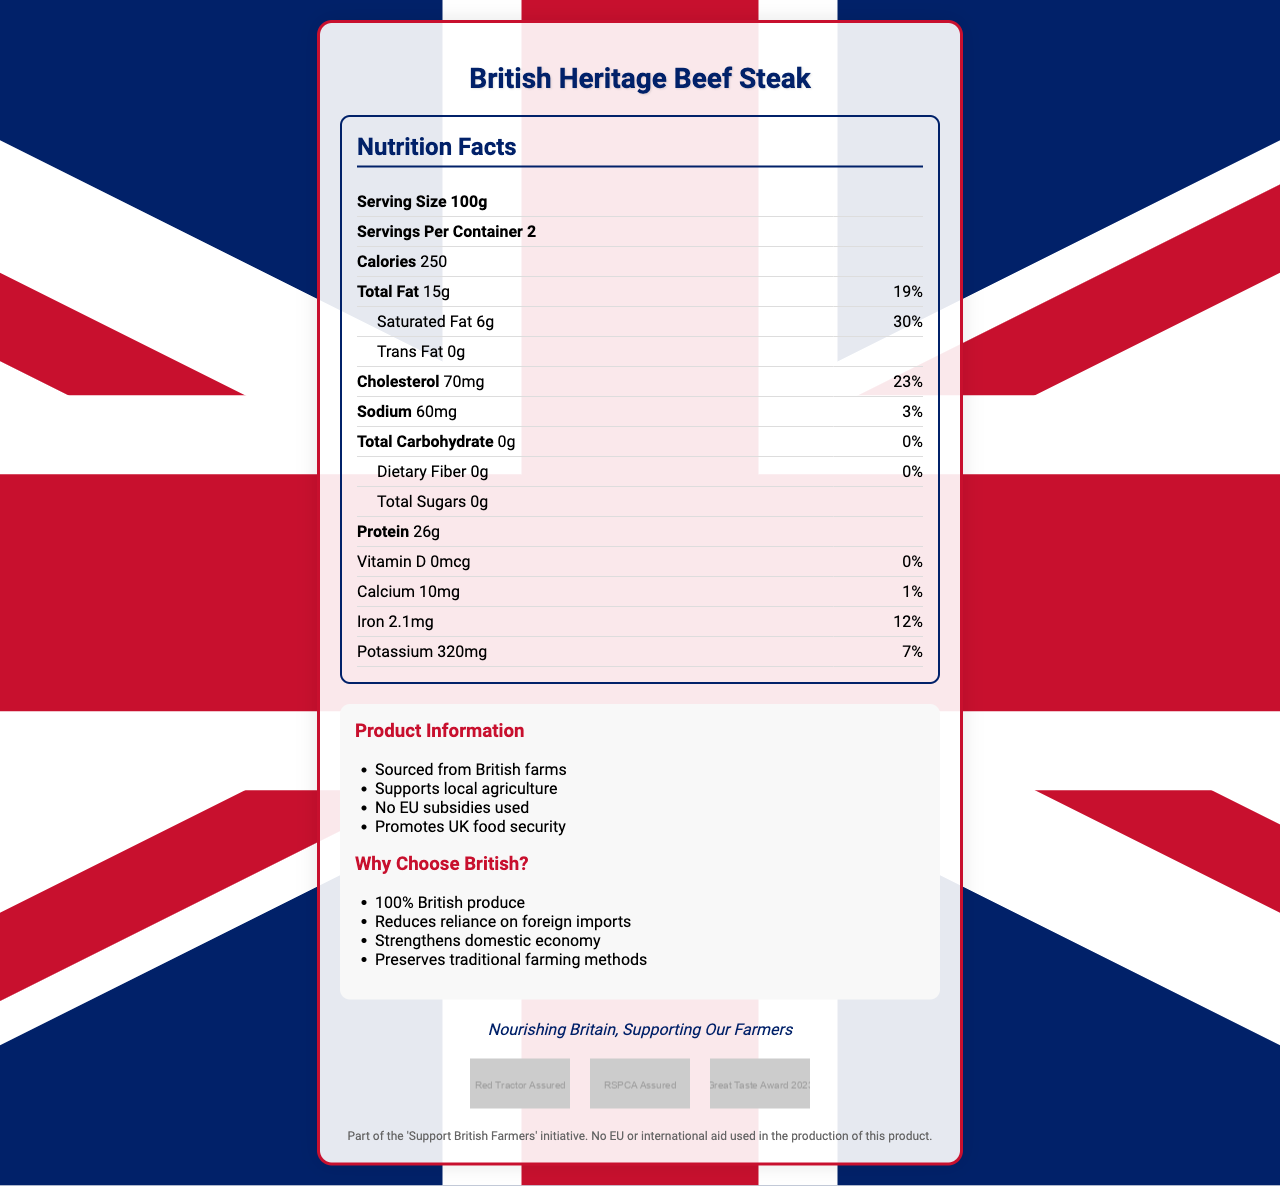What is the serving size of British Heritage Beef Steak? The serving size is listed explicitly in the nutrition facts section of the document.
Answer: 100g What is the percentage of daily value for saturated fat? The daily value percentage is listed next to the saturated fat amount of 6g in the nutrition facts table.
Answer: 30% How much iron is in one serving? The amount of iron per serving is specified in the nutrition facts.
Answer: 2.1mg What certifications does the British Heritage Beef Steak have? The certifications are displayed in the certifications section with the logos and names.
Answer: Red Tractor Assured, RSPCA Assured, Great Taste Award 2023 How many calories are there per container? Each serving has 250 calories and there are 2 servings per container (250 calories * 2 servings = 500 calories).
Answer: 500 calories What is the total fat content? The amount of total fat is clearly mentioned in the nutrition facts section as 15g.
Answer: 15g Which of the following is a reason to choose British products listed in the document?
1. Improves mental health
2. Reduces reliance on foreign imports
3. Increases employment in tech industry
4. Promotes vegetarianism The reasons given include "Reduces reliance on foreign imports" among others.
Answer: 2 Which of these is NOT a part of the product's conservative appeal?
A. Strengthens domestic economy
B. Enhances brain health
C. Preserves traditional farming methods
D. 100% British produce The enhancements to brain health are not mentioned as part of the document's conservative appeal.
Answer: B Does the product use EU or international aid in its production? The disclaimer of the product states that no EU or international aid was used in producing this product.
Answer: No How much protein does one serving of British Heritage Beef Steak contain? The amount of protein per serving is listed in the nutrition facts section.
Answer: 26g Summarize the main idea of the document. The document provides an overview of the nutritional content, sourcing information, reasons for supporting the product, and quality certifications.
Answer: The British Heritage Beef Steak nutrition label highlights the product's nutrition facts, emphasizes it is sourced from British farms without EU subsidies, and promotes local agriculture. It includes additional information and certifications to ensure quality and support for the UK economy. Does the product have any dietary fiber? The dietary fiber amount is listed as 0g in the nutrition facts section.
Answer: No Based on the document, what is the Vitamin D content in the British Heritage Beef Steak? The nutrition facts section specifies that the Vitamin D content is 0mcg.
Answer: 0mcg Is the product suitable for a low-sodium diet? The sodium content per serving is 60mg, which is a low amount constituting just 3% of the daily value.
Answer: Yes What are the prominent visual elements on the document? These design elements are listed under the union jack elements section of the document.
Answer: Red, white, and blue color scheme; Union Jack flag in the background; Silhouette of British Isles Is this product part of an international aid initiative? The disclaimer clearly states that no EU or international aid was used in producing this product.
Answer: No What specific British certification logos are shown on the product label? The certifications logos are mentioned and visually depicted in the certifications section.
Answer: Red Tractor Assured, RSPCA Assured, Great Taste Award 2023 Does the label mention any use of EU subsidies? The additional info and the disclaimer both specify that no EU subsidies were used.
Answer: No Is there any charitable component mentioned in the document to support international communities? There is no mention of any charitable component related to international aid; the focus is solely on supporting British farmers and local agriculture.
Answer: No 